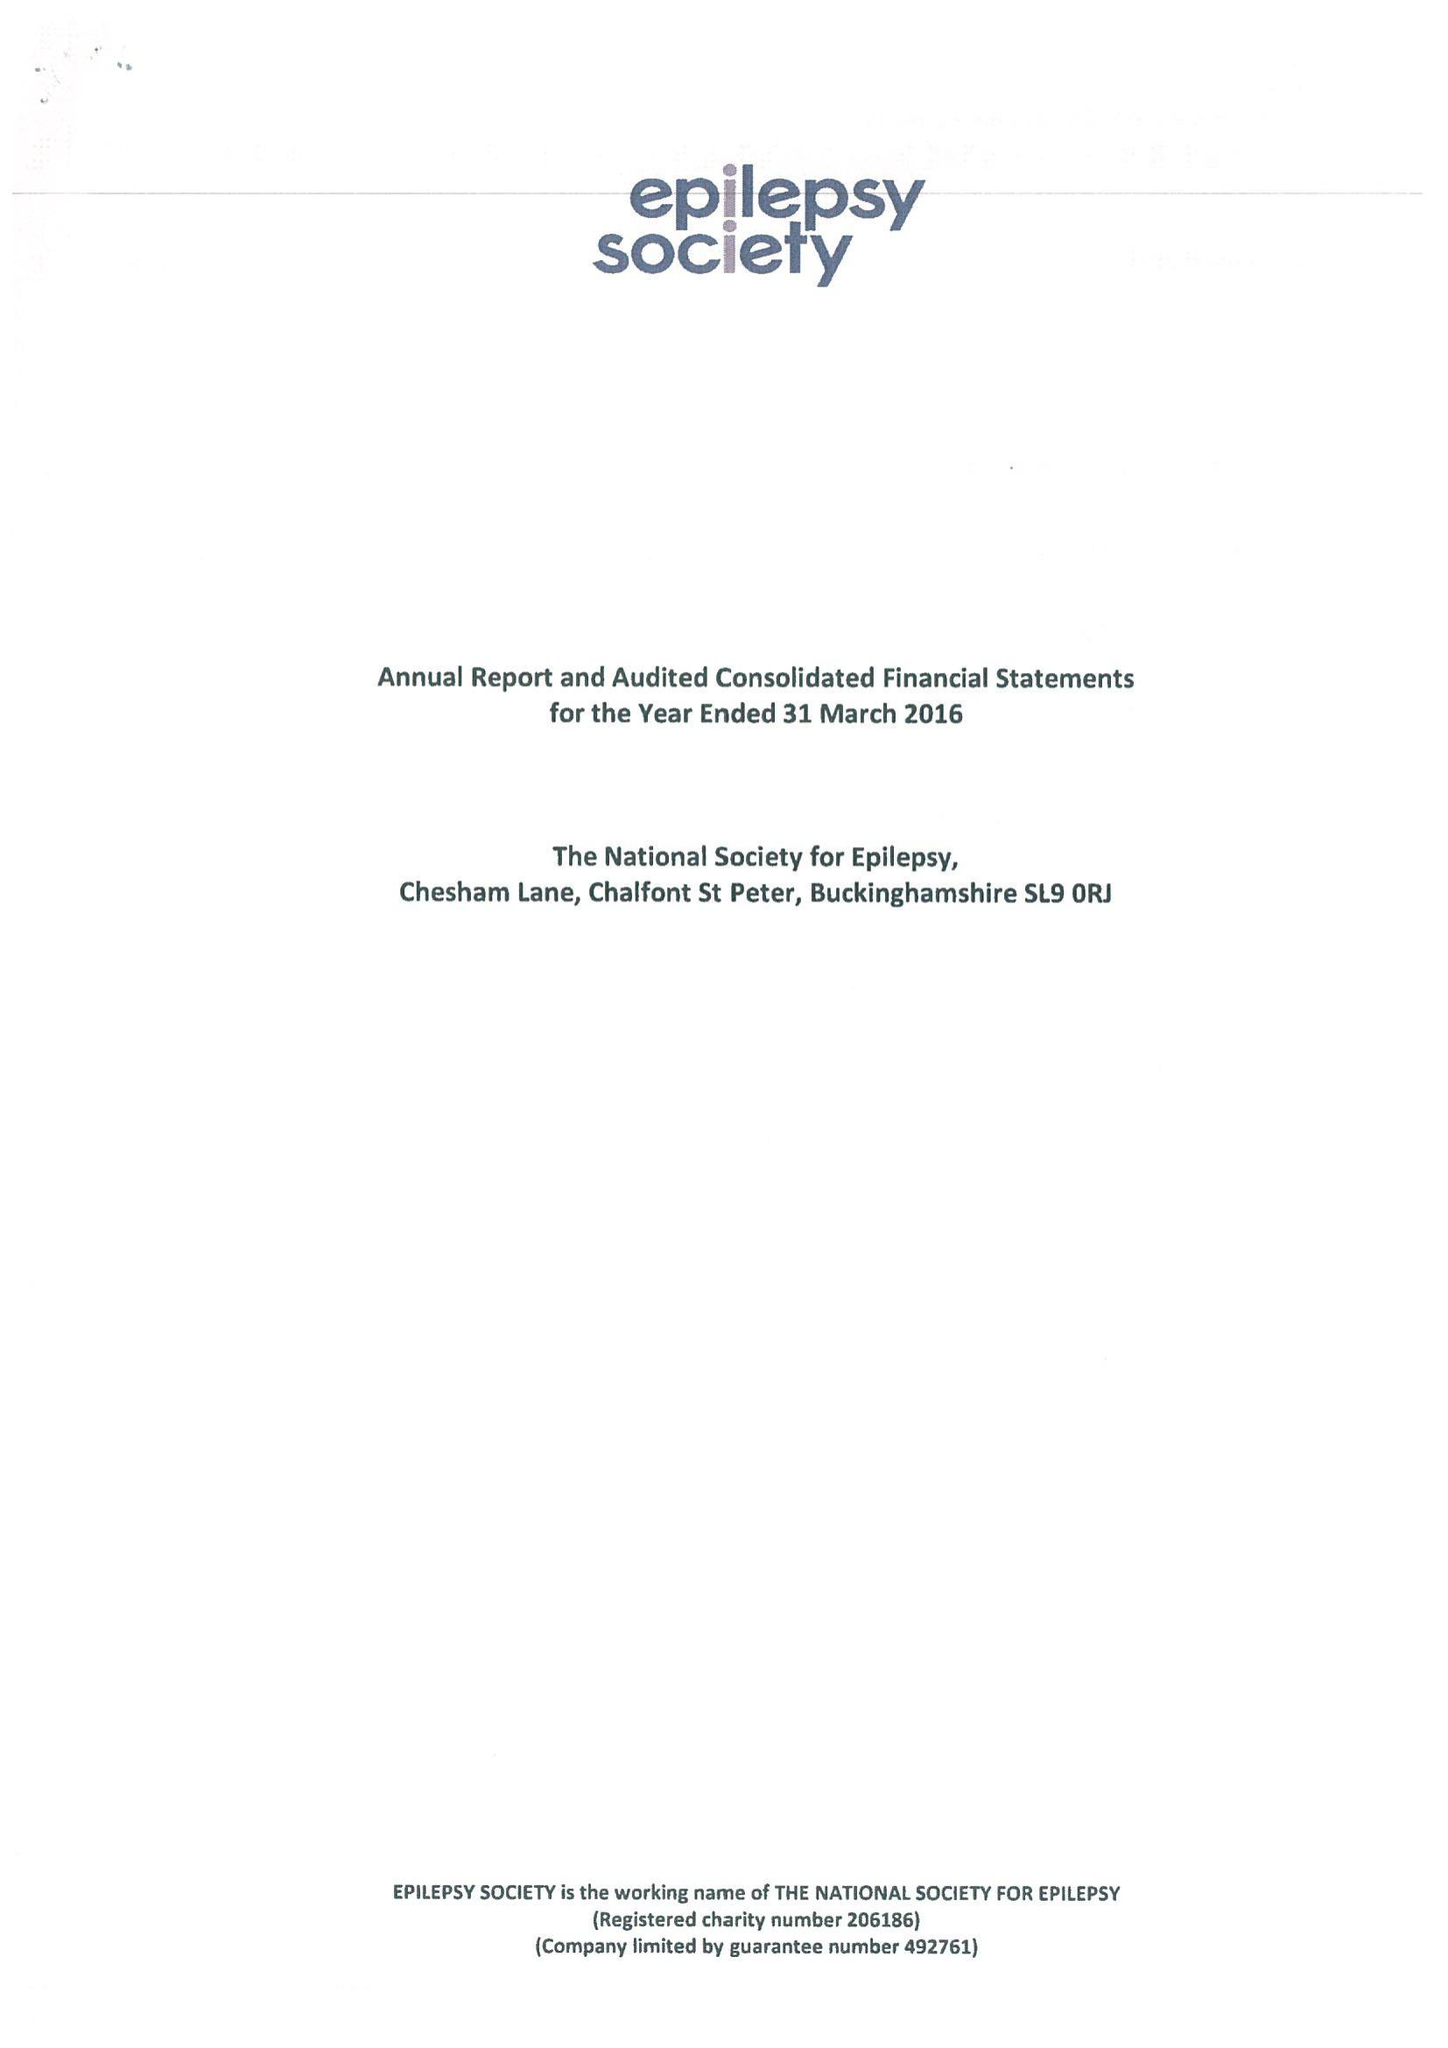What is the value for the address__street_line?
Answer the question using a single word or phrase. CHESHAM LANE 